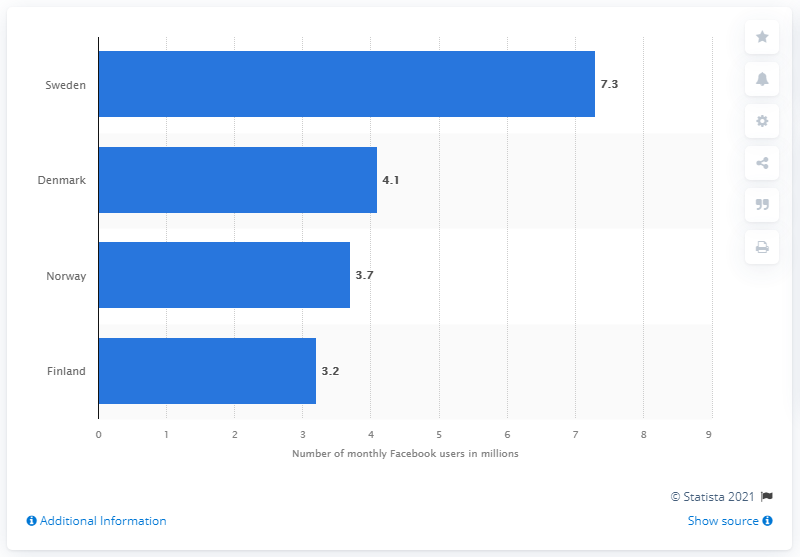Mention a couple of crucial points in this snapshot. In early 2018, there were approximately 7.3 active monthly Facebook users in Sweden. Denmark had 4.1 million active monthly Facebook users in early 2018, making it the Nordic country with the highest number of active social media users. 